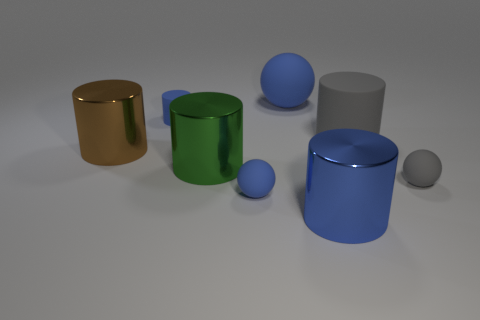Subtract all gray matte balls. How many balls are left? 2 Add 1 big cyan matte cylinders. How many objects exist? 9 Subtract all blue spheres. How many spheres are left? 1 Subtract 3 cylinders. How many cylinders are left? 2 Subtract all rubber things. Subtract all purple things. How many objects are left? 3 Add 1 rubber cylinders. How many rubber cylinders are left? 3 Add 1 big blue metallic objects. How many big blue metallic objects exist? 2 Subtract 1 brown cylinders. How many objects are left? 7 Subtract all cylinders. How many objects are left? 3 Subtract all brown spheres. Subtract all gray blocks. How many spheres are left? 3 